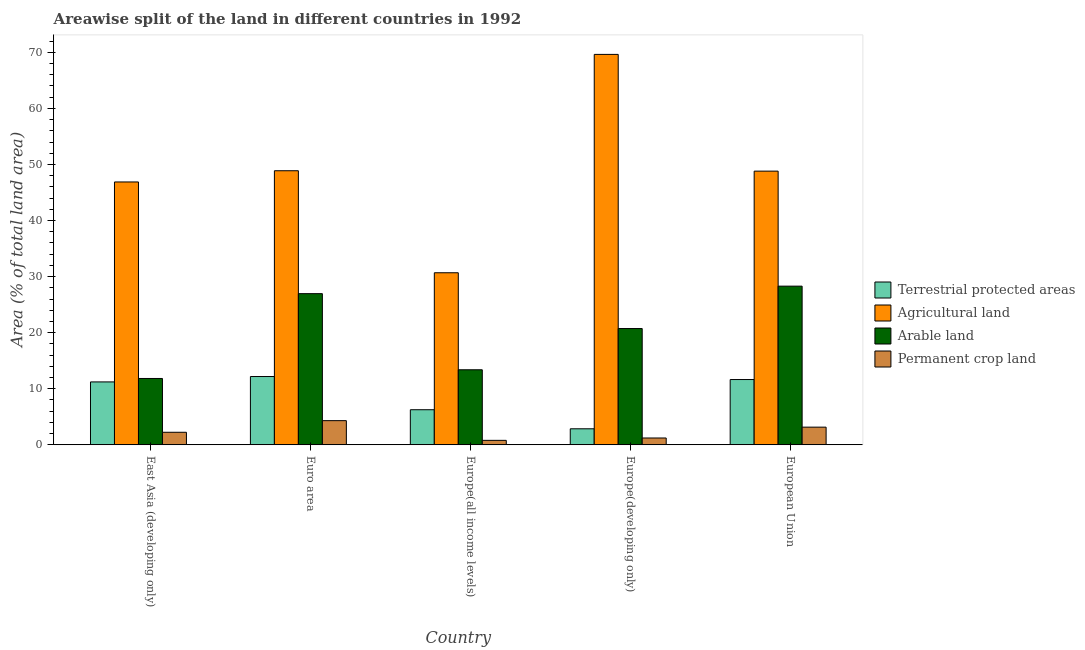How many different coloured bars are there?
Your response must be concise. 4. How many groups of bars are there?
Provide a succinct answer. 5. Are the number of bars per tick equal to the number of legend labels?
Provide a succinct answer. Yes. What is the label of the 4th group of bars from the left?
Offer a very short reply. Europe(developing only). What is the percentage of area under agricultural land in Euro area?
Your response must be concise. 48.88. Across all countries, what is the maximum percentage of area under permanent crop land?
Your answer should be very brief. 4.31. Across all countries, what is the minimum percentage of land under terrestrial protection?
Ensure brevity in your answer.  2.85. In which country was the percentage of area under agricultural land minimum?
Offer a very short reply. Europe(all income levels). What is the total percentage of land under terrestrial protection in the graph?
Your answer should be very brief. 44.14. What is the difference between the percentage of area under permanent crop land in East Asia (developing only) and that in Europe(developing only)?
Your answer should be very brief. 1.02. What is the difference between the percentage of land under terrestrial protection in East Asia (developing only) and the percentage of area under permanent crop land in Europe(all income levels)?
Ensure brevity in your answer.  10.42. What is the average percentage of area under permanent crop land per country?
Provide a short and direct response. 2.34. What is the difference between the percentage of area under permanent crop land and percentage of area under arable land in Europe(developing only)?
Provide a succinct answer. -19.52. What is the ratio of the percentage of area under permanent crop land in East Asia (developing only) to that in European Union?
Your answer should be compact. 0.71. What is the difference between the highest and the second highest percentage of land under terrestrial protection?
Your answer should be compact. 0.54. What is the difference between the highest and the lowest percentage of area under arable land?
Keep it short and to the point. 16.47. In how many countries, is the percentage of land under terrestrial protection greater than the average percentage of land under terrestrial protection taken over all countries?
Your response must be concise. 3. Is it the case that in every country, the sum of the percentage of land under terrestrial protection and percentage of area under agricultural land is greater than the sum of percentage of area under permanent crop land and percentage of area under arable land?
Give a very brief answer. Yes. What does the 2nd bar from the left in Europe(developing only) represents?
Ensure brevity in your answer.  Agricultural land. What does the 2nd bar from the right in European Union represents?
Your response must be concise. Arable land. Is it the case that in every country, the sum of the percentage of land under terrestrial protection and percentage of area under agricultural land is greater than the percentage of area under arable land?
Your answer should be very brief. Yes. How many bars are there?
Make the answer very short. 20. How many countries are there in the graph?
Offer a very short reply. 5. What is the difference between two consecutive major ticks on the Y-axis?
Give a very brief answer. 10. Are the values on the major ticks of Y-axis written in scientific E-notation?
Offer a terse response. No. How many legend labels are there?
Your response must be concise. 4. How are the legend labels stacked?
Provide a short and direct response. Vertical. What is the title of the graph?
Offer a very short reply. Areawise split of the land in different countries in 1992. What is the label or title of the Y-axis?
Your response must be concise. Area (% of total land area). What is the Area (% of total land area) in Terrestrial protected areas in East Asia (developing only)?
Your answer should be very brief. 11.22. What is the Area (% of total land area) in Agricultural land in East Asia (developing only)?
Offer a terse response. 46.88. What is the Area (% of total land area) of Arable land in East Asia (developing only)?
Your answer should be very brief. 11.83. What is the Area (% of total land area) in Permanent crop land in East Asia (developing only)?
Keep it short and to the point. 2.23. What is the Area (% of total land area) in Terrestrial protected areas in Euro area?
Provide a short and direct response. 12.18. What is the Area (% of total land area) in Agricultural land in Euro area?
Ensure brevity in your answer.  48.88. What is the Area (% of total land area) in Arable land in Euro area?
Your response must be concise. 26.96. What is the Area (% of total land area) in Permanent crop land in Euro area?
Your answer should be very brief. 4.31. What is the Area (% of total land area) in Terrestrial protected areas in Europe(all income levels)?
Your response must be concise. 6.26. What is the Area (% of total land area) of Agricultural land in Europe(all income levels)?
Your response must be concise. 30.68. What is the Area (% of total land area) of Arable land in Europe(all income levels)?
Your answer should be compact. 13.38. What is the Area (% of total land area) of Permanent crop land in Europe(all income levels)?
Keep it short and to the point. 0.79. What is the Area (% of total land area) in Terrestrial protected areas in Europe(developing only)?
Provide a short and direct response. 2.85. What is the Area (% of total land area) of Agricultural land in Europe(developing only)?
Your answer should be compact. 69.63. What is the Area (% of total land area) in Arable land in Europe(developing only)?
Provide a short and direct response. 20.74. What is the Area (% of total land area) in Permanent crop land in Europe(developing only)?
Give a very brief answer. 1.21. What is the Area (% of total land area) in Terrestrial protected areas in European Union?
Provide a succinct answer. 11.64. What is the Area (% of total land area) in Agricultural land in European Union?
Provide a succinct answer. 48.81. What is the Area (% of total land area) in Arable land in European Union?
Make the answer very short. 28.3. What is the Area (% of total land area) of Permanent crop land in European Union?
Give a very brief answer. 3.15. Across all countries, what is the maximum Area (% of total land area) in Terrestrial protected areas?
Your response must be concise. 12.18. Across all countries, what is the maximum Area (% of total land area) of Agricultural land?
Your answer should be very brief. 69.63. Across all countries, what is the maximum Area (% of total land area) of Arable land?
Give a very brief answer. 28.3. Across all countries, what is the maximum Area (% of total land area) in Permanent crop land?
Provide a succinct answer. 4.31. Across all countries, what is the minimum Area (% of total land area) of Terrestrial protected areas?
Offer a terse response. 2.85. Across all countries, what is the minimum Area (% of total land area) in Agricultural land?
Your answer should be very brief. 30.68. Across all countries, what is the minimum Area (% of total land area) in Arable land?
Your response must be concise. 11.83. Across all countries, what is the minimum Area (% of total land area) of Permanent crop land?
Your answer should be compact. 0.79. What is the total Area (% of total land area) of Terrestrial protected areas in the graph?
Your response must be concise. 44.14. What is the total Area (% of total land area) of Agricultural land in the graph?
Keep it short and to the point. 244.89. What is the total Area (% of total land area) in Arable land in the graph?
Keep it short and to the point. 101.2. What is the total Area (% of total land area) of Permanent crop land in the graph?
Your answer should be very brief. 11.7. What is the difference between the Area (% of total land area) of Terrestrial protected areas in East Asia (developing only) and that in Euro area?
Keep it short and to the point. -0.96. What is the difference between the Area (% of total land area) in Agricultural land in East Asia (developing only) and that in Euro area?
Your response must be concise. -2. What is the difference between the Area (% of total land area) in Arable land in East Asia (developing only) and that in Euro area?
Your answer should be very brief. -15.13. What is the difference between the Area (% of total land area) of Permanent crop land in East Asia (developing only) and that in Euro area?
Keep it short and to the point. -2.07. What is the difference between the Area (% of total land area) in Terrestrial protected areas in East Asia (developing only) and that in Europe(all income levels)?
Your response must be concise. 4.96. What is the difference between the Area (% of total land area) of Agricultural land in East Asia (developing only) and that in Europe(all income levels)?
Your answer should be compact. 16.2. What is the difference between the Area (% of total land area) of Arable land in East Asia (developing only) and that in Europe(all income levels)?
Provide a succinct answer. -1.55. What is the difference between the Area (% of total land area) of Permanent crop land in East Asia (developing only) and that in Europe(all income levels)?
Offer a terse response. 1.44. What is the difference between the Area (% of total land area) of Terrestrial protected areas in East Asia (developing only) and that in Europe(developing only)?
Offer a terse response. 8.36. What is the difference between the Area (% of total land area) in Agricultural land in East Asia (developing only) and that in Europe(developing only)?
Your response must be concise. -22.75. What is the difference between the Area (% of total land area) of Arable land in East Asia (developing only) and that in Europe(developing only)?
Keep it short and to the point. -8.91. What is the difference between the Area (% of total land area) of Permanent crop land in East Asia (developing only) and that in Europe(developing only)?
Make the answer very short. 1.02. What is the difference between the Area (% of total land area) in Terrestrial protected areas in East Asia (developing only) and that in European Union?
Keep it short and to the point. -0.42. What is the difference between the Area (% of total land area) in Agricultural land in East Asia (developing only) and that in European Union?
Make the answer very short. -1.93. What is the difference between the Area (% of total land area) in Arable land in East Asia (developing only) and that in European Union?
Give a very brief answer. -16.47. What is the difference between the Area (% of total land area) of Permanent crop land in East Asia (developing only) and that in European Union?
Ensure brevity in your answer.  -0.91. What is the difference between the Area (% of total land area) of Terrestrial protected areas in Euro area and that in Europe(all income levels)?
Offer a terse response. 5.92. What is the difference between the Area (% of total land area) in Agricultural land in Euro area and that in Europe(all income levels)?
Give a very brief answer. 18.2. What is the difference between the Area (% of total land area) of Arable land in Euro area and that in Europe(all income levels)?
Your answer should be compact. 13.58. What is the difference between the Area (% of total land area) of Permanent crop land in Euro area and that in Europe(all income levels)?
Your answer should be very brief. 3.51. What is the difference between the Area (% of total land area) of Terrestrial protected areas in Euro area and that in Europe(developing only)?
Keep it short and to the point. 9.32. What is the difference between the Area (% of total land area) in Agricultural land in Euro area and that in Europe(developing only)?
Provide a succinct answer. -20.75. What is the difference between the Area (% of total land area) in Arable land in Euro area and that in Europe(developing only)?
Your answer should be compact. 6.22. What is the difference between the Area (% of total land area) of Permanent crop land in Euro area and that in Europe(developing only)?
Offer a very short reply. 3.09. What is the difference between the Area (% of total land area) of Terrestrial protected areas in Euro area and that in European Union?
Provide a succinct answer. 0.54. What is the difference between the Area (% of total land area) in Agricultural land in Euro area and that in European Union?
Offer a very short reply. 0.07. What is the difference between the Area (% of total land area) in Arable land in Euro area and that in European Union?
Provide a short and direct response. -1.34. What is the difference between the Area (% of total land area) of Permanent crop land in Euro area and that in European Union?
Keep it short and to the point. 1.16. What is the difference between the Area (% of total land area) of Terrestrial protected areas in Europe(all income levels) and that in Europe(developing only)?
Give a very brief answer. 3.4. What is the difference between the Area (% of total land area) in Agricultural land in Europe(all income levels) and that in Europe(developing only)?
Make the answer very short. -38.95. What is the difference between the Area (% of total land area) in Arable land in Europe(all income levels) and that in Europe(developing only)?
Provide a succinct answer. -7.36. What is the difference between the Area (% of total land area) in Permanent crop land in Europe(all income levels) and that in Europe(developing only)?
Make the answer very short. -0.42. What is the difference between the Area (% of total land area) of Terrestrial protected areas in Europe(all income levels) and that in European Union?
Give a very brief answer. -5.38. What is the difference between the Area (% of total land area) in Agricultural land in Europe(all income levels) and that in European Union?
Your answer should be compact. -18.13. What is the difference between the Area (% of total land area) of Arable land in Europe(all income levels) and that in European Union?
Your answer should be very brief. -14.92. What is the difference between the Area (% of total land area) of Permanent crop land in Europe(all income levels) and that in European Union?
Make the answer very short. -2.35. What is the difference between the Area (% of total land area) in Terrestrial protected areas in Europe(developing only) and that in European Union?
Offer a terse response. -8.79. What is the difference between the Area (% of total land area) of Agricultural land in Europe(developing only) and that in European Union?
Provide a succinct answer. 20.82. What is the difference between the Area (% of total land area) of Arable land in Europe(developing only) and that in European Union?
Keep it short and to the point. -7.56. What is the difference between the Area (% of total land area) in Permanent crop land in Europe(developing only) and that in European Union?
Offer a terse response. -1.93. What is the difference between the Area (% of total land area) in Terrestrial protected areas in East Asia (developing only) and the Area (% of total land area) in Agricultural land in Euro area?
Your answer should be very brief. -37.67. What is the difference between the Area (% of total land area) of Terrestrial protected areas in East Asia (developing only) and the Area (% of total land area) of Arable land in Euro area?
Provide a succinct answer. -15.74. What is the difference between the Area (% of total land area) in Terrestrial protected areas in East Asia (developing only) and the Area (% of total land area) in Permanent crop land in Euro area?
Offer a very short reply. 6.91. What is the difference between the Area (% of total land area) of Agricultural land in East Asia (developing only) and the Area (% of total land area) of Arable land in Euro area?
Offer a terse response. 19.92. What is the difference between the Area (% of total land area) of Agricultural land in East Asia (developing only) and the Area (% of total land area) of Permanent crop land in Euro area?
Give a very brief answer. 42.57. What is the difference between the Area (% of total land area) in Arable land in East Asia (developing only) and the Area (% of total land area) in Permanent crop land in Euro area?
Your response must be concise. 7.52. What is the difference between the Area (% of total land area) in Terrestrial protected areas in East Asia (developing only) and the Area (% of total land area) in Agricultural land in Europe(all income levels)?
Provide a short and direct response. -19.47. What is the difference between the Area (% of total land area) of Terrestrial protected areas in East Asia (developing only) and the Area (% of total land area) of Arable land in Europe(all income levels)?
Your answer should be compact. -2.17. What is the difference between the Area (% of total land area) in Terrestrial protected areas in East Asia (developing only) and the Area (% of total land area) in Permanent crop land in Europe(all income levels)?
Keep it short and to the point. 10.42. What is the difference between the Area (% of total land area) of Agricultural land in East Asia (developing only) and the Area (% of total land area) of Arable land in Europe(all income levels)?
Provide a short and direct response. 33.5. What is the difference between the Area (% of total land area) in Agricultural land in East Asia (developing only) and the Area (% of total land area) in Permanent crop land in Europe(all income levels)?
Keep it short and to the point. 46.09. What is the difference between the Area (% of total land area) of Arable land in East Asia (developing only) and the Area (% of total land area) of Permanent crop land in Europe(all income levels)?
Offer a terse response. 11.04. What is the difference between the Area (% of total land area) of Terrestrial protected areas in East Asia (developing only) and the Area (% of total land area) of Agricultural land in Europe(developing only)?
Keep it short and to the point. -58.42. What is the difference between the Area (% of total land area) in Terrestrial protected areas in East Asia (developing only) and the Area (% of total land area) in Arable land in Europe(developing only)?
Your answer should be very brief. -9.52. What is the difference between the Area (% of total land area) in Terrestrial protected areas in East Asia (developing only) and the Area (% of total land area) in Permanent crop land in Europe(developing only)?
Provide a short and direct response. 10. What is the difference between the Area (% of total land area) in Agricultural land in East Asia (developing only) and the Area (% of total land area) in Arable land in Europe(developing only)?
Provide a short and direct response. 26.14. What is the difference between the Area (% of total land area) in Agricultural land in East Asia (developing only) and the Area (% of total land area) in Permanent crop land in Europe(developing only)?
Your answer should be very brief. 45.67. What is the difference between the Area (% of total land area) in Arable land in East Asia (developing only) and the Area (% of total land area) in Permanent crop land in Europe(developing only)?
Your answer should be very brief. 10.62. What is the difference between the Area (% of total land area) in Terrestrial protected areas in East Asia (developing only) and the Area (% of total land area) in Agricultural land in European Union?
Provide a succinct answer. -37.6. What is the difference between the Area (% of total land area) of Terrestrial protected areas in East Asia (developing only) and the Area (% of total land area) of Arable land in European Union?
Provide a short and direct response. -17.08. What is the difference between the Area (% of total land area) of Terrestrial protected areas in East Asia (developing only) and the Area (% of total land area) of Permanent crop land in European Union?
Your response must be concise. 8.07. What is the difference between the Area (% of total land area) in Agricultural land in East Asia (developing only) and the Area (% of total land area) in Arable land in European Union?
Ensure brevity in your answer.  18.58. What is the difference between the Area (% of total land area) in Agricultural land in East Asia (developing only) and the Area (% of total land area) in Permanent crop land in European Union?
Your answer should be compact. 43.73. What is the difference between the Area (% of total land area) in Arable land in East Asia (developing only) and the Area (% of total land area) in Permanent crop land in European Union?
Keep it short and to the point. 8.68. What is the difference between the Area (% of total land area) of Terrestrial protected areas in Euro area and the Area (% of total land area) of Agricultural land in Europe(all income levels)?
Give a very brief answer. -18.51. What is the difference between the Area (% of total land area) of Terrestrial protected areas in Euro area and the Area (% of total land area) of Arable land in Europe(all income levels)?
Offer a terse response. -1.2. What is the difference between the Area (% of total land area) of Terrestrial protected areas in Euro area and the Area (% of total land area) of Permanent crop land in Europe(all income levels)?
Provide a succinct answer. 11.38. What is the difference between the Area (% of total land area) in Agricultural land in Euro area and the Area (% of total land area) in Arable land in Europe(all income levels)?
Keep it short and to the point. 35.5. What is the difference between the Area (% of total land area) of Agricultural land in Euro area and the Area (% of total land area) of Permanent crop land in Europe(all income levels)?
Ensure brevity in your answer.  48.09. What is the difference between the Area (% of total land area) of Arable land in Euro area and the Area (% of total land area) of Permanent crop land in Europe(all income levels)?
Offer a terse response. 26.17. What is the difference between the Area (% of total land area) in Terrestrial protected areas in Euro area and the Area (% of total land area) in Agricultural land in Europe(developing only)?
Your answer should be very brief. -57.46. What is the difference between the Area (% of total land area) in Terrestrial protected areas in Euro area and the Area (% of total land area) in Arable land in Europe(developing only)?
Offer a very short reply. -8.56. What is the difference between the Area (% of total land area) in Terrestrial protected areas in Euro area and the Area (% of total land area) in Permanent crop land in Europe(developing only)?
Provide a succinct answer. 10.96. What is the difference between the Area (% of total land area) of Agricultural land in Euro area and the Area (% of total land area) of Arable land in Europe(developing only)?
Your answer should be very brief. 28.14. What is the difference between the Area (% of total land area) of Agricultural land in Euro area and the Area (% of total land area) of Permanent crop land in Europe(developing only)?
Make the answer very short. 47.67. What is the difference between the Area (% of total land area) of Arable land in Euro area and the Area (% of total land area) of Permanent crop land in Europe(developing only)?
Make the answer very short. 25.74. What is the difference between the Area (% of total land area) of Terrestrial protected areas in Euro area and the Area (% of total land area) of Agricultural land in European Union?
Your answer should be very brief. -36.63. What is the difference between the Area (% of total land area) of Terrestrial protected areas in Euro area and the Area (% of total land area) of Arable land in European Union?
Make the answer very short. -16.12. What is the difference between the Area (% of total land area) in Terrestrial protected areas in Euro area and the Area (% of total land area) in Permanent crop land in European Union?
Offer a very short reply. 9.03. What is the difference between the Area (% of total land area) of Agricultural land in Euro area and the Area (% of total land area) of Arable land in European Union?
Your answer should be very brief. 20.58. What is the difference between the Area (% of total land area) in Agricultural land in Euro area and the Area (% of total land area) in Permanent crop land in European Union?
Make the answer very short. 45.73. What is the difference between the Area (% of total land area) in Arable land in Euro area and the Area (% of total land area) in Permanent crop land in European Union?
Provide a succinct answer. 23.81. What is the difference between the Area (% of total land area) in Terrestrial protected areas in Europe(all income levels) and the Area (% of total land area) in Agricultural land in Europe(developing only)?
Offer a terse response. -63.38. What is the difference between the Area (% of total land area) of Terrestrial protected areas in Europe(all income levels) and the Area (% of total land area) of Arable land in Europe(developing only)?
Give a very brief answer. -14.48. What is the difference between the Area (% of total land area) in Terrestrial protected areas in Europe(all income levels) and the Area (% of total land area) in Permanent crop land in Europe(developing only)?
Keep it short and to the point. 5.04. What is the difference between the Area (% of total land area) of Agricultural land in Europe(all income levels) and the Area (% of total land area) of Arable land in Europe(developing only)?
Offer a very short reply. 9.95. What is the difference between the Area (% of total land area) in Agricultural land in Europe(all income levels) and the Area (% of total land area) in Permanent crop land in Europe(developing only)?
Ensure brevity in your answer.  29.47. What is the difference between the Area (% of total land area) in Arable land in Europe(all income levels) and the Area (% of total land area) in Permanent crop land in Europe(developing only)?
Offer a terse response. 12.17. What is the difference between the Area (% of total land area) in Terrestrial protected areas in Europe(all income levels) and the Area (% of total land area) in Agricultural land in European Union?
Offer a terse response. -42.56. What is the difference between the Area (% of total land area) of Terrestrial protected areas in Europe(all income levels) and the Area (% of total land area) of Arable land in European Union?
Provide a short and direct response. -22.04. What is the difference between the Area (% of total land area) in Terrestrial protected areas in Europe(all income levels) and the Area (% of total land area) in Permanent crop land in European Union?
Your answer should be compact. 3.11. What is the difference between the Area (% of total land area) of Agricultural land in Europe(all income levels) and the Area (% of total land area) of Arable land in European Union?
Ensure brevity in your answer.  2.39. What is the difference between the Area (% of total land area) in Agricultural land in Europe(all income levels) and the Area (% of total land area) in Permanent crop land in European Union?
Offer a terse response. 27.54. What is the difference between the Area (% of total land area) of Arable land in Europe(all income levels) and the Area (% of total land area) of Permanent crop land in European Union?
Your answer should be compact. 10.23. What is the difference between the Area (% of total land area) of Terrestrial protected areas in Europe(developing only) and the Area (% of total land area) of Agricultural land in European Union?
Provide a short and direct response. -45.96. What is the difference between the Area (% of total land area) of Terrestrial protected areas in Europe(developing only) and the Area (% of total land area) of Arable land in European Union?
Ensure brevity in your answer.  -25.44. What is the difference between the Area (% of total land area) in Terrestrial protected areas in Europe(developing only) and the Area (% of total land area) in Permanent crop land in European Union?
Offer a very short reply. -0.29. What is the difference between the Area (% of total land area) in Agricultural land in Europe(developing only) and the Area (% of total land area) in Arable land in European Union?
Give a very brief answer. 41.34. What is the difference between the Area (% of total land area) of Agricultural land in Europe(developing only) and the Area (% of total land area) of Permanent crop land in European Union?
Keep it short and to the point. 66.49. What is the difference between the Area (% of total land area) of Arable land in Europe(developing only) and the Area (% of total land area) of Permanent crop land in European Union?
Give a very brief answer. 17.59. What is the average Area (% of total land area) in Terrestrial protected areas per country?
Offer a terse response. 8.83. What is the average Area (% of total land area) in Agricultural land per country?
Provide a short and direct response. 48.98. What is the average Area (% of total land area) of Arable land per country?
Offer a very short reply. 20.24. What is the average Area (% of total land area) in Permanent crop land per country?
Keep it short and to the point. 2.34. What is the difference between the Area (% of total land area) of Terrestrial protected areas and Area (% of total land area) of Agricultural land in East Asia (developing only)?
Your answer should be compact. -35.67. What is the difference between the Area (% of total land area) in Terrestrial protected areas and Area (% of total land area) in Arable land in East Asia (developing only)?
Your response must be concise. -0.61. What is the difference between the Area (% of total land area) in Terrestrial protected areas and Area (% of total land area) in Permanent crop land in East Asia (developing only)?
Provide a succinct answer. 8.98. What is the difference between the Area (% of total land area) of Agricultural land and Area (% of total land area) of Arable land in East Asia (developing only)?
Offer a terse response. 35.05. What is the difference between the Area (% of total land area) in Agricultural land and Area (% of total land area) in Permanent crop land in East Asia (developing only)?
Provide a succinct answer. 44.65. What is the difference between the Area (% of total land area) in Arable land and Area (% of total land area) in Permanent crop land in East Asia (developing only)?
Provide a succinct answer. 9.59. What is the difference between the Area (% of total land area) in Terrestrial protected areas and Area (% of total land area) in Agricultural land in Euro area?
Ensure brevity in your answer.  -36.7. What is the difference between the Area (% of total land area) in Terrestrial protected areas and Area (% of total land area) in Arable land in Euro area?
Keep it short and to the point. -14.78. What is the difference between the Area (% of total land area) in Terrestrial protected areas and Area (% of total land area) in Permanent crop land in Euro area?
Give a very brief answer. 7.87. What is the difference between the Area (% of total land area) in Agricultural land and Area (% of total land area) in Arable land in Euro area?
Give a very brief answer. 21.92. What is the difference between the Area (% of total land area) of Agricultural land and Area (% of total land area) of Permanent crop land in Euro area?
Offer a very short reply. 44.57. What is the difference between the Area (% of total land area) in Arable land and Area (% of total land area) in Permanent crop land in Euro area?
Keep it short and to the point. 22.65. What is the difference between the Area (% of total land area) of Terrestrial protected areas and Area (% of total land area) of Agricultural land in Europe(all income levels)?
Offer a very short reply. -24.43. What is the difference between the Area (% of total land area) of Terrestrial protected areas and Area (% of total land area) of Arable land in Europe(all income levels)?
Your answer should be compact. -7.12. What is the difference between the Area (% of total land area) in Terrestrial protected areas and Area (% of total land area) in Permanent crop land in Europe(all income levels)?
Your response must be concise. 5.46. What is the difference between the Area (% of total land area) of Agricultural land and Area (% of total land area) of Arable land in Europe(all income levels)?
Provide a succinct answer. 17.3. What is the difference between the Area (% of total land area) of Agricultural land and Area (% of total land area) of Permanent crop land in Europe(all income levels)?
Provide a succinct answer. 29.89. What is the difference between the Area (% of total land area) in Arable land and Area (% of total land area) in Permanent crop land in Europe(all income levels)?
Give a very brief answer. 12.59. What is the difference between the Area (% of total land area) of Terrestrial protected areas and Area (% of total land area) of Agricultural land in Europe(developing only)?
Make the answer very short. -66.78. What is the difference between the Area (% of total land area) of Terrestrial protected areas and Area (% of total land area) of Arable land in Europe(developing only)?
Offer a terse response. -17.88. What is the difference between the Area (% of total land area) of Terrestrial protected areas and Area (% of total land area) of Permanent crop land in Europe(developing only)?
Offer a terse response. 1.64. What is the difference between the Area (% of total land area) of Agricultural land and Area (% of total land area) of Arable land in Europe(developing only)?
Ensure brevity in your answer.  48.9. What is the difference between the Area (% of total land area) of Agricultural land and Area (% of total land area) of Permanent crop land in Europe(developing only)?
Keep it short and to the point. 68.42. What is the difference between the Area (% of total land area) of Arable land and Area (% of total land area) of Permanent crop land in Europe(developing only)?
Your response must be concise. 19.52. What is the difference between the Area (% of total land area) of Terrestrial protected areas and Area (% of total land area) of Agricultural land in European Union?
Keep it short and to the point. -37.17. What is the difference between the Area (% of total land area) of Terrestrial protected areas and Area (% of total land area) of Arable land in European Union?
Your answer should be very brief. -16.66. What is the difference between the Area (% of total land area) in Terrestrial protected areas and Area (% of total land area) in Permanent crop land in European Union?
Make the answer very short. 8.49. What is the difference between the Area (% of total land area) in Agricultural land and Area (% of total land area) in Arable land in European Union?
Keep it short and to the point. 20.51. What is the difference between the Area (% of total land area) of Agricultural land and Area (% of total land area) of Permanent crop land in European Union?
Provide a succinct answer. 45.66. What is the difference between the Area (% of total land area) of Arable land and Area (% of total land area) of Permanent crop land in European Union?
Your answer should be very brief. 25.15. What is the ratio of the Area (% of total land area) in Terrestrial protected areas in East Asia (developing only) to that in Euro area?
Make the answer very short. 0.92. What is the ratio of the Area (% of total land area) in Agricultural land in East Asia (developing only) to that in Euro area?
Provide a succinct answer. 0.96. What is the ratio of the Area (% of total land area) of Arable land in East Asia (developing only) to that in Euro area?
Provide a short and direct response. 0.44. What is the ratio of the Area (% of total land area) of Permanent crop land in East Asia (developing only) to that in Euro area?
Your answer should be compact. 0.52. What is the ratio of the Area (% of total land area) of Terrestrial protected areas in East Asia (developing only) to that in Europe(all income levels)?
Keep it short and to the point. 1.79. What is the ratio of the Area (% of total land area) in Agricultural land in East Asia (developing only) to that in Europe(all income levels)?
Ensure brevity in your answer.  1.53. What is the ratio of the Area (% of total land area) of Arable land in East Asia (developing only) to that in Europe(all income levels)?
Your answer should be compact. 0.88. What is the ratio of the Area (% of total land area) in Permanent crop land in East Asia (developing only) to that in Europe(all income levels)?
Your response must be concise. 2.82. What is the ratio of the Area (% of total land area) of Terrestrial protected areas in East Asia (developing only) to that in Europe(developing only)?
Your answer should be very brief. 3.93. What is the ratio of the Area (% of total land area) in Agricultural land in East Asia (developing only) to that in Europe(developing only)?
Ensure brevity in your answer.  0.67. What is the ratio of the Area (% of total land area) in Arable land in East Asia (developing only) to that in Europe(developing only)?
Provide a short and direct response. 0.57. What is the ratio of the Area (% of total land area) in Permanent crop land in East Asia (developing only) to that in Europe(developing only)?
Your answer should be compact. 1.84. What is the ratio of the Area (% of total land area) of Terrestrial protected areas in East Asia (developing only) to that in European Union?
Provide a succinct answer. 0.96. What is the ratio of the Area (% of total land area) in Agricultural land in East Asia (developing only) to that in European Union?
Ensure brevity in your answer.  0.96. What is the ratio of the Area (% of total land area) of Arable land in East Asia (developing only) to that in European Union?
Your response must be concise. 0.42. What is the ratio of the Area (% of total land area) of Permanent crop land in East Asia (developing only) to that in European Union?
Make the answer very short. 0.71. What is the ratio of the Area (% of total land area) in Terrestrial protected areas in Euro area to that in Europe(all income levels)?
Your response must be concise. 1.95. What is the ratio of the Area (% of total land area) of Agricultural land in Euro area to that in Europe(all income levels)?
Your answer should be very brief. 1.59. What is the ratio of the Area (% of total land area) of Arable land in Euro area to that in Europe(all income levels)?
Offer a very short reply. 2.01. What is the ratio of the Area (% of total land area) of Permanent crop land in Euro area to that in Europe(all income levels)?
Ensure brevity in your answer.  5.43. What is the ratio of the Area (% of total land area) of Terrestrial protected areas in Euro area to that in Europe(developing only)?
Ensure brevity in your answer.  4.27. What is the ratio of the Area (% of total land area) of Agricultural land in Euro area to that in Europe(developing only)?
Provide a succinct answer. 0.7. What is the ratio of the Area (% of total land area) in Arable land in Euro area to that in Europe(developing only)?
Offer a very short reply. 1.3. What is the ratio of the Area (% of total land area) in Permanent crop land in Euro area to that in Europe(developing only)?
Provide a short and direct response. 3.55. What is the ratio of the Area (% of total land area) in Terrestrial protected areas in Euro area to that in European Union?
Offer a very short reply. 1.05. What is the ratio of the Area (% of total land area) of Agricultural land in Euro area to that in European Union?
Provide a short and direct response. 1. What is the ratio of the Area (% of total land area) in Arable land in Euro area to that in European Union?
Ensure brevity in your answer.  0.95. What is the ratio of the Area (% of total land area) of Permanent crop land in Euro area to that in European Union?
Keep it short and to the point. 1.37. What is the ratio of the Area (% of total land area) of Terrestrial protected areas in Europe(all income levels) to that in Europe(developing only)?
Provide a short and direct response. 2.19. What is the ratio of the Area (% of total land area) of Agricultural land in Europe(all income levels) to that in Europe(developing only)?
Your answer should be compact. 0.44. What is the ratio of the Area (% of total land area) in Arable land in Europe(all income levels) to that in Europe(developing only)?
Provide a succinct answer. 0.65. What is the ratio of the Area (% of total land area) in Permanent crop land in Europe(all income levels) to that in Europe(developing only)?
Provide a short and direct response. 0.65. What is the ratio of the Area (% of total land area) in Terrestrial protected areas in Europe(all income levels) to that in European Union?
Give a very brief answer. 0.54. What is the ratio of the Area (% of total land area) of Agricultural land in Europe(all income levels) to that in European Union?
Offer a terse response. 0.63. What is the ratio of the Area (% of total land area) in Arable land in Europe(all income levels) to that in European Union?
Give a very brief answer. 0.47. What is the ratio of the Area (% of total land area) of Permanent crop land in Europe(all income levels) to that in European Union?
Keep it short and to the point. 0.25. What is the ratio of the Area (% of total land area) of Terrestrial protected areas in Europe(developing only) to that in European Union?
Offer a very short reply. 0.25. What is the ratio of the Area (% of total land area) of Agricultural land in Europe(developing only) to that in European Union?
Your answer should be compact. 1.43. What is the ratio of the Area (% of total land area) in Arable land in Europe(developing only) to that in European Union?
Your response must be concise. 0.73. What is the ratio of the Area (% of total land area) in Permanent crop land in Europe(developing only) to that in European Union?
Your answer should be very brief. 0.39. What is the difference between the highest and the second highest Area (% of total land area) in Terrestrial protected areas?
Provide a succinct answer. 0.54. What is the difference between the highest and the second highest Area (% of total land area) in Agricultural land?
Make the answer very short. 20.75. What is the difference between the highest and the second highest Area (% of total land area) of Arable land?
Offer a very short reply. 1.34. What is the difference between the highest and the second highest Area (% of total land area) of Permanent crop land?
Ensure brevity in your answer.  1.16. What is the difference between the highest and the lowest Area (% of total land area) of Terrestrial protected areas?
Your answer should be compact. 9.32. What is the difference between the highest and the lowest Area (% of total land area) in Agricultural land?
Provide a short and direct response. 38.95. What is the difference between the highest and the lowest Area (% of total land area) of Arable land?
Your answer should be very brief. 16.47. What is the difference between the highest and the lowest Area (% of total land area) in Permanent crop land?
Offer a terse response. 3.51. 